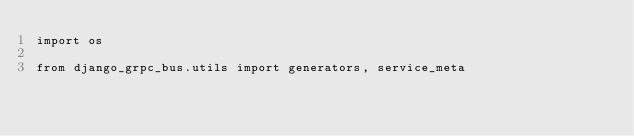<code> <loc_0><loc_0><loc_500><loc_500><_Python_>import os

from django_grpc_bus.utils import generators, service_meta</code> 